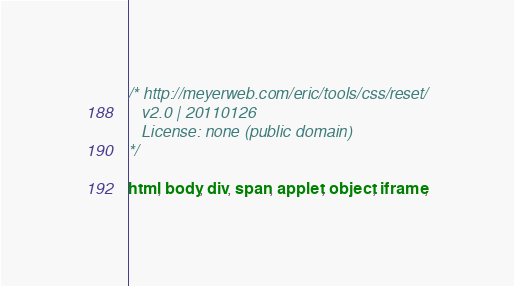<code> <loc_0><loc_0><loc_500><loc_500><_CSS_>/* http://meyerweb.com/eric/tools/css/reset/
   v2.0 | 20110126
   License: none (public domain)
*/

html, body, div, span, applet, object, iframe,</code> 